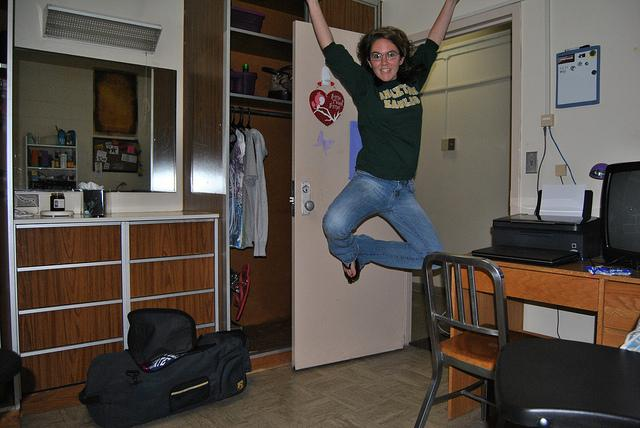Where is the woman jumping?

Choices:
A) dorm room
B) hotel room
C) restaurant
D) hospital room dorm room 